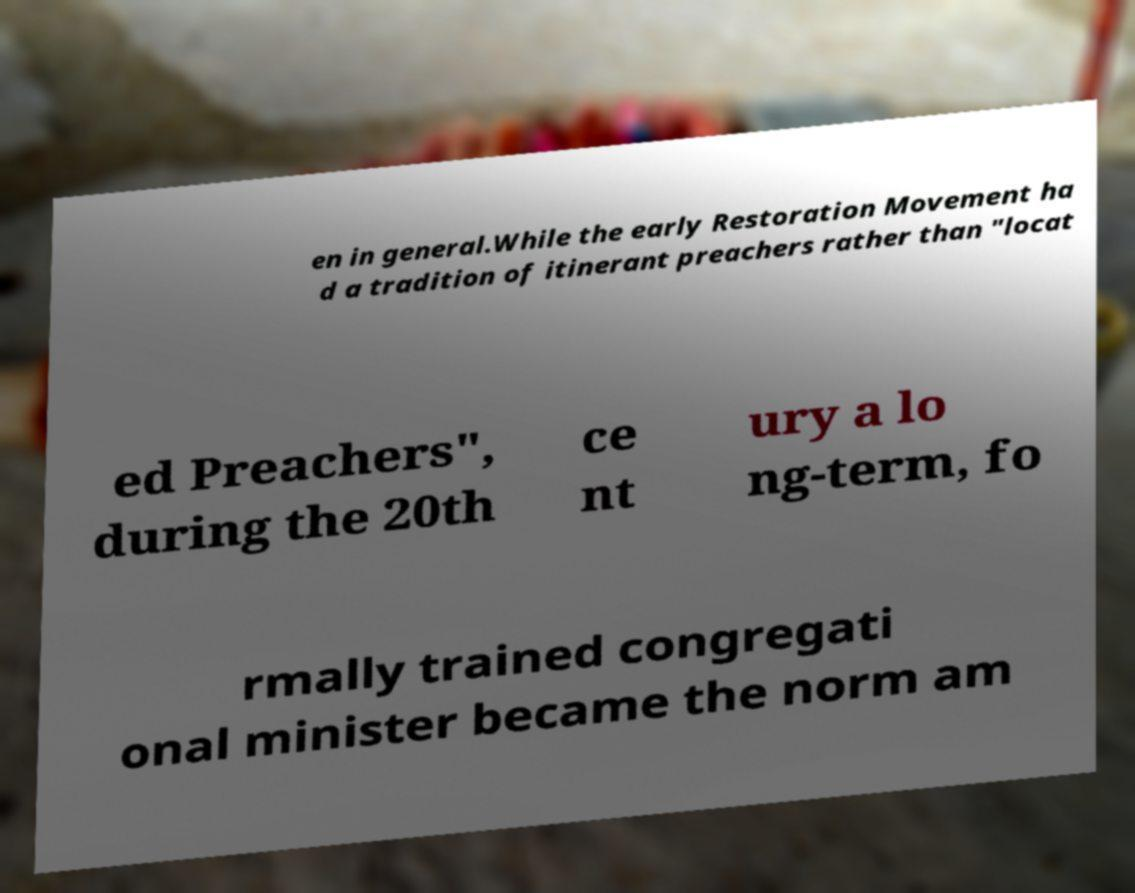Can you accurately transcribe the text from the provided image for me? en in general.While the early Restoration Movement ha d a tradition of itinerant preachers rather than "locat ed Preachers", during the 20th ce nt ury a lo ng-term, fo rmally trained congregati onal minister became the norm am 